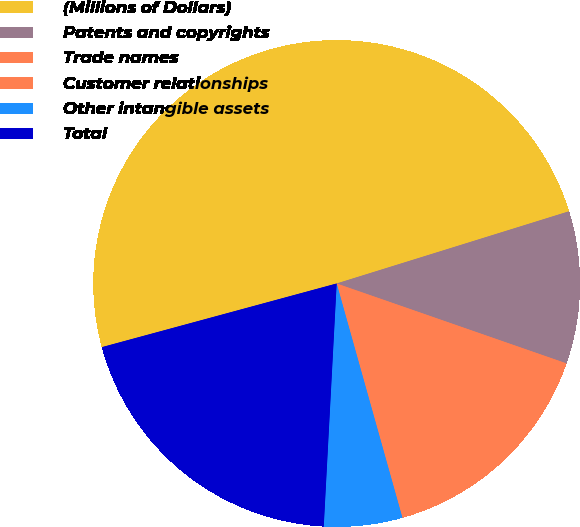Convert chart to OTSL. <chart><loc_0><loc_0><loc_500><loc_500><pie_chart><fcel>(Millions of Dollars)<fcel>Patents and copyrights<fcel>Trade names<fcel>Customer relationships<fcel>Other intangible assets<fcel>Total<nl><fcel>49.42%<fcel>10.12%<fcel>0.29%<fcel>15.03%<fcel>5.2%<fcel>19.94%<nl></chart> 